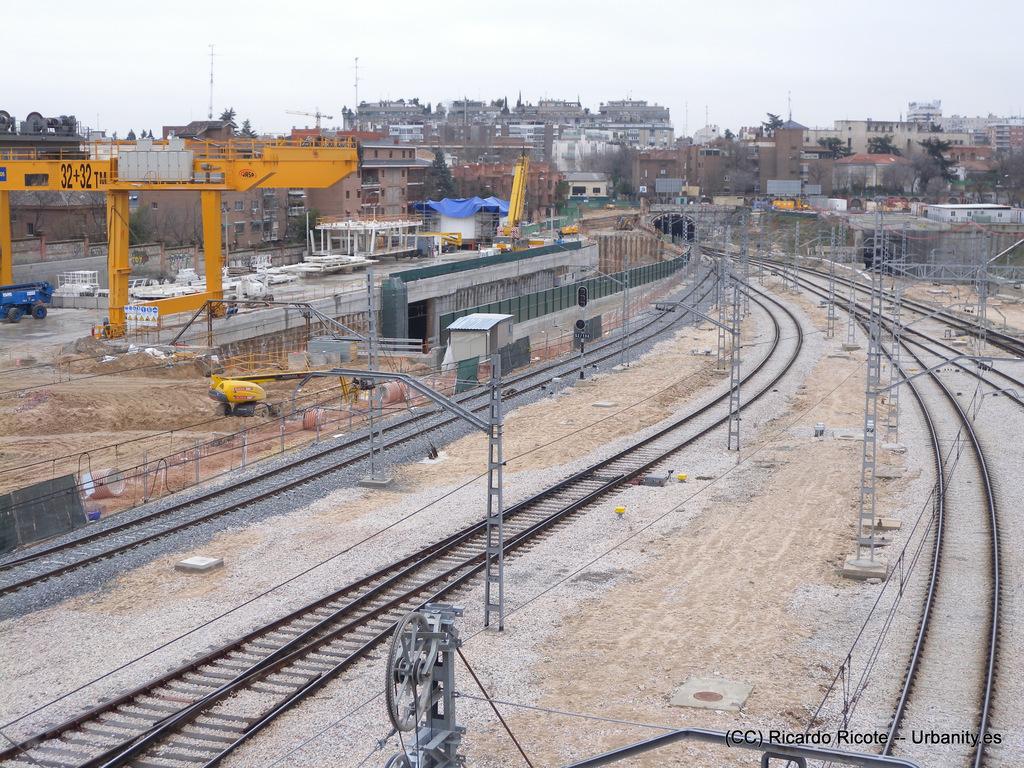What is the number on the yellow equipment?
Keep it short and to the point. 32. Track is very closely?
Your answer should be very brief. Yes. 